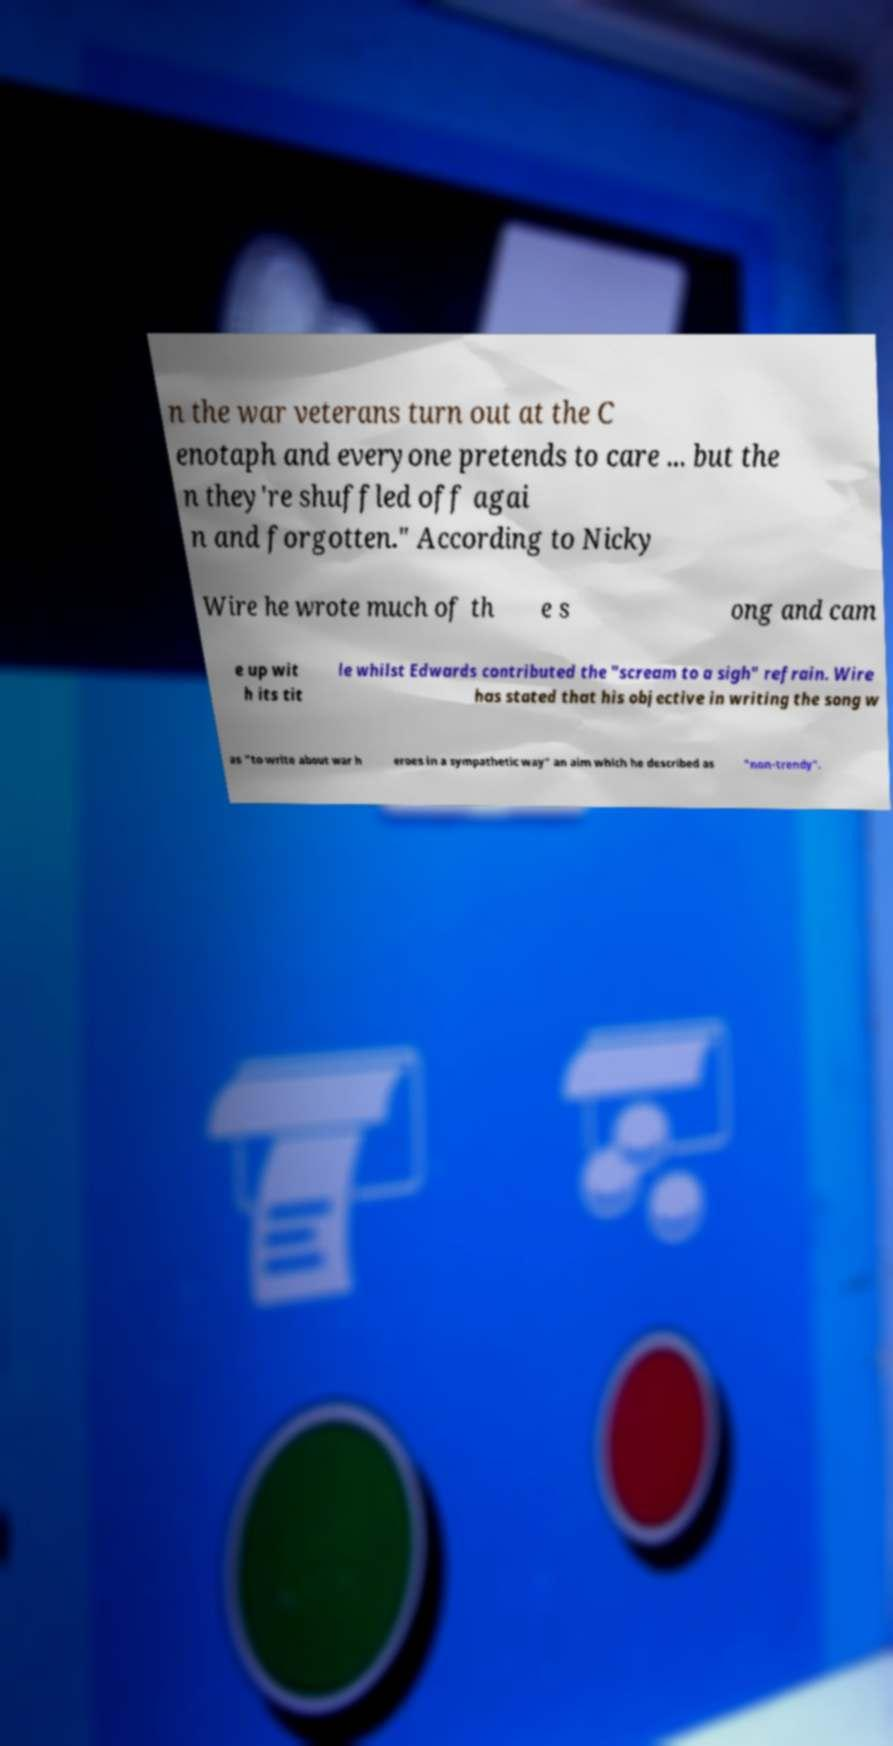Can you read and provide the text displayed in the image?This photo seems to have some interesting text. Can you extract and type it out for me? n the war veterans turn out at the C enotaph and everyone pretends to care ... but the n they're shuffled off agai n and forgotten." According to Nicky Wire he wrote much of th e s ong and cam e up wit h its tit le whilst Edwards contributed the "scream to a sigh" refrain. Wire has stated that his objective in writing the song w as "to write about war h eroes in a sympathetic way" an aim which he described as "non-trendy". 